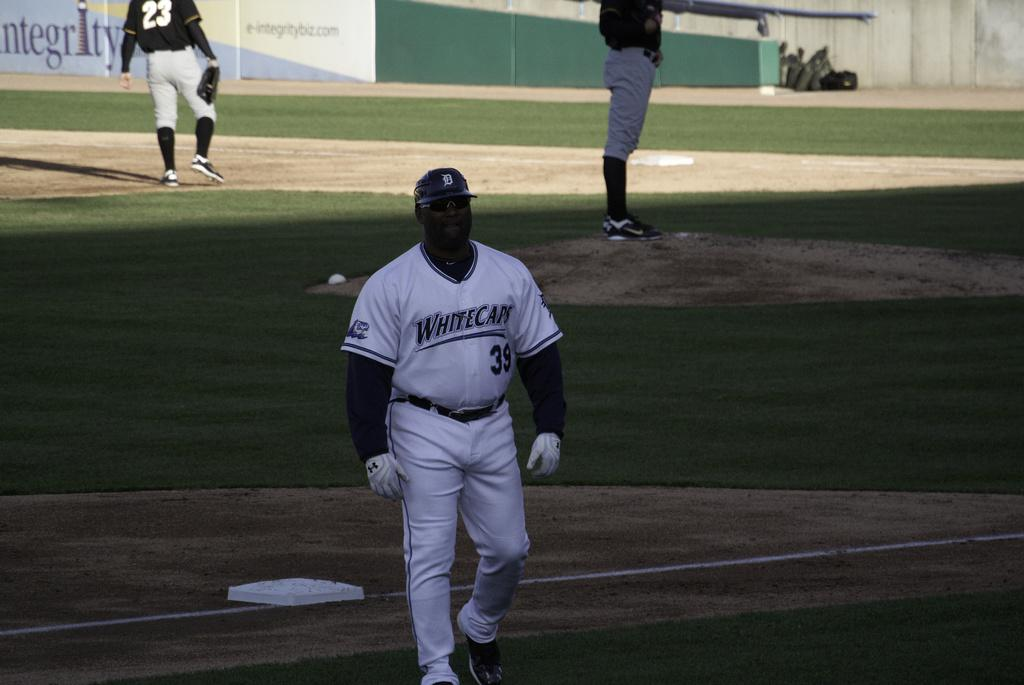<image>
Render a clear and concise summary of the photo. a man in a White Caps number 39 jersey walks off a field 